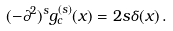Convert formula to latex. <formula><loc_0><loc_0><loc_500><loc_500>( - \partial ^ { 2 } ) ^ { s } g _ { c } ^ { ( s ) } ( x ) = 2 s \delta ( x ) \, .</formula> 